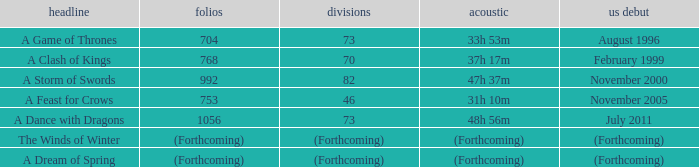Which audio has a Title of a storm of swords? 47h 37m. 